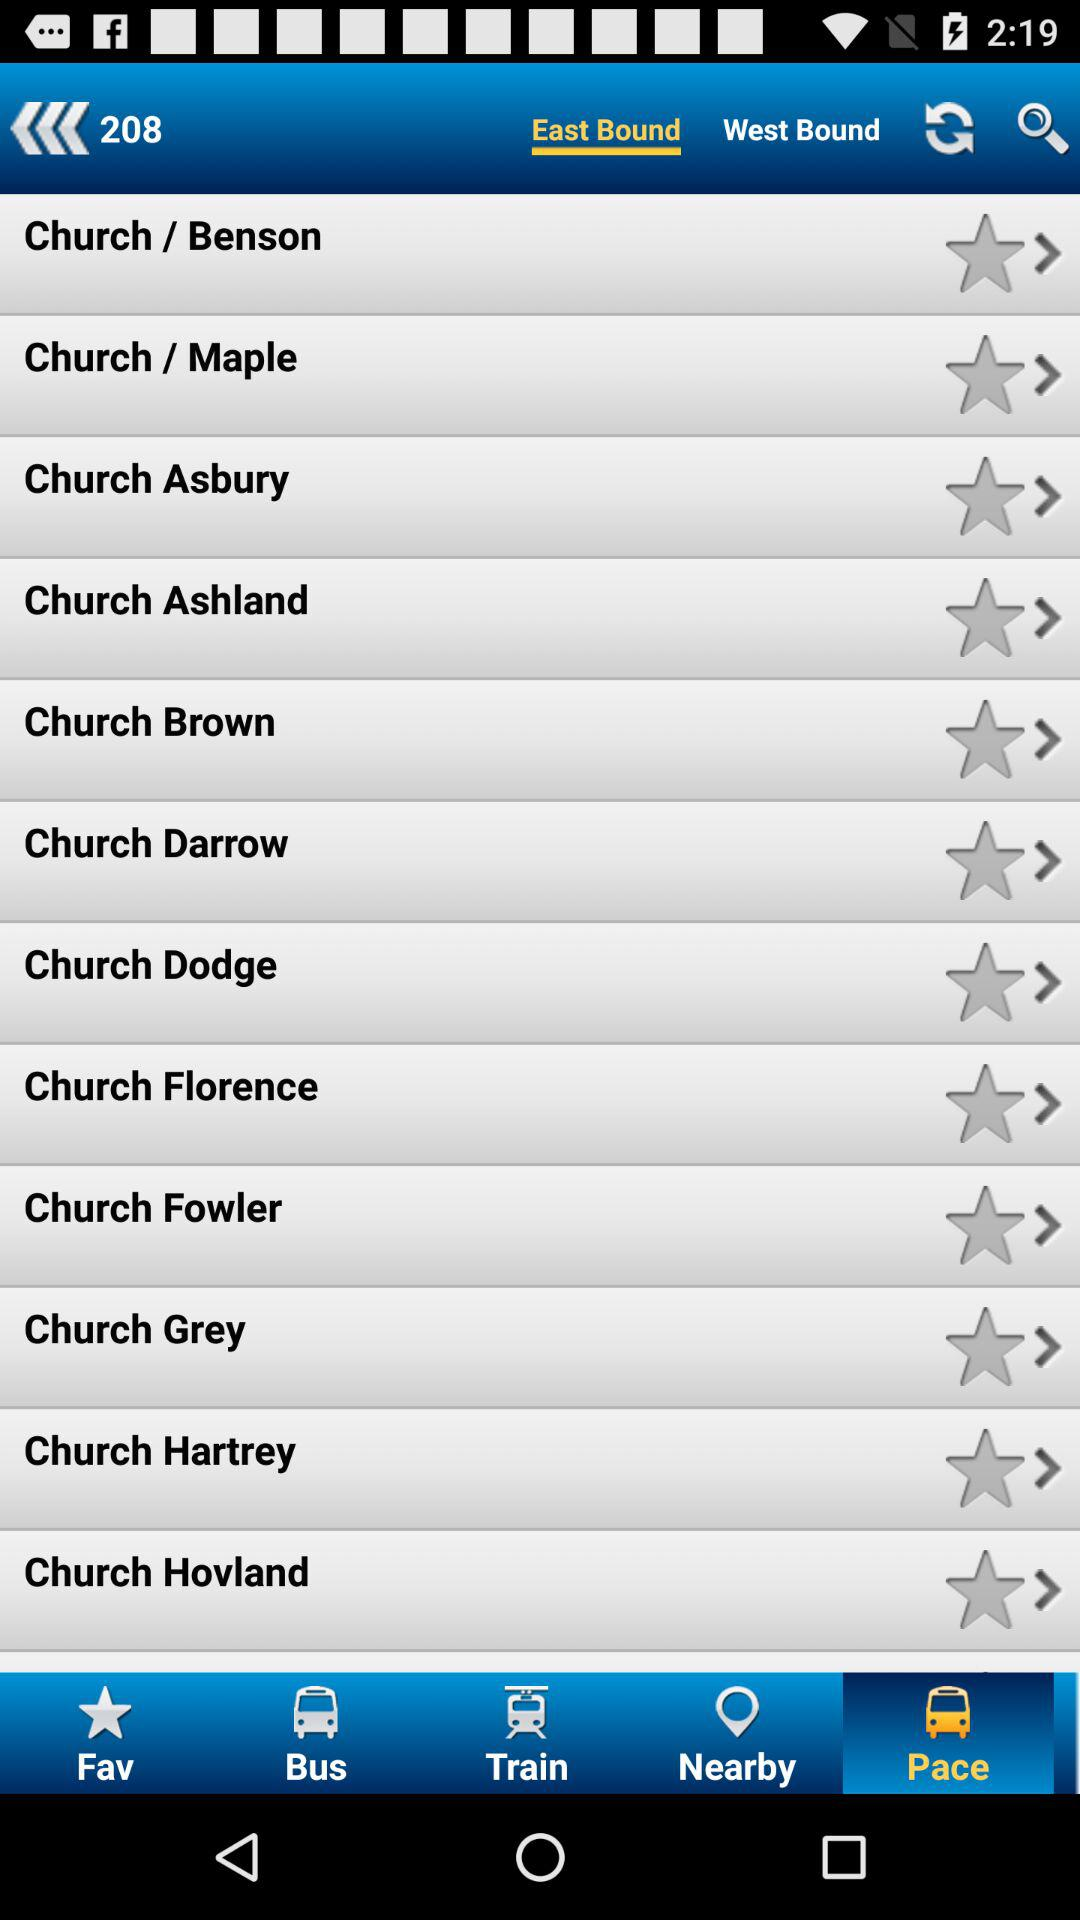Which tab am I on? You are on the "Pace" and "East Bound" tabs. 